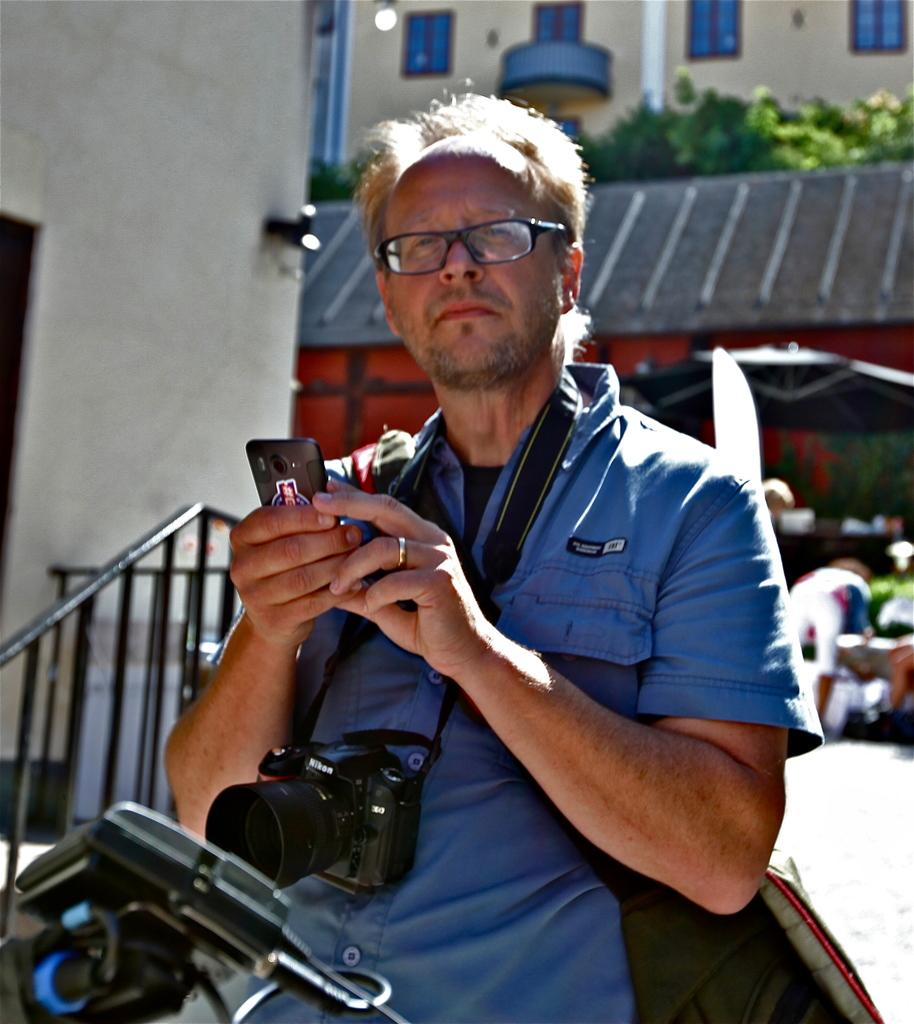What is the man in the image doing? The man is standing in the image. What is the man wearing in the image? The man is wearing a camera in the image. What is the man holding in the image? The man is holding a smartphone in the image. What can be seen on the left side of the image? There are stairs on the left side of the image. What is visible in the background of the image? There are buildings and trees in the background of the image. What caption is written on the apparatus the man is wearing? There is no caption written on the camera the man is wearing in the image. What trick is the man performing with the smartphone in the image? There is no trick being performed with the smartphone in the image; the man is simply holding it. 